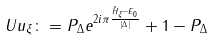Convert formula to latex. <formula><loc_0><loc_0><loc_500><loc_500>\ U u _ { \xi } \colon = P _ { \Delta } e ^ { 2 i \pi \frac { \hat { H } _ { \xi } - E _ { 0 } } { | \Delta | } } + 1 - P _ { \Delta }</formula> 